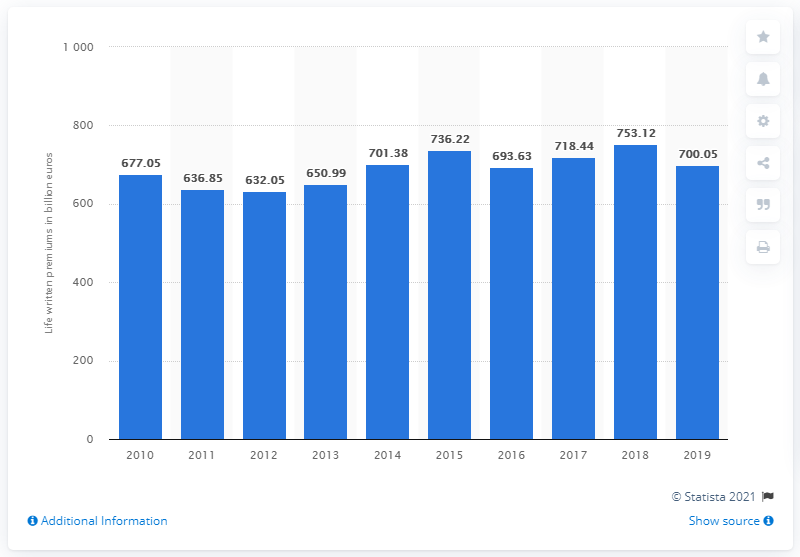Draw attention to some important aspects in this diagram. The direct gross written premiums on the European life insurance market in 2019 were approximately 700.05. According to the European life insurance market in 2019, the total amount of direct gross written premiums was 753.12. In 2018, the gross domestic product (GDP) was the highest among all the years. In 2011, companies offering life insurance reported paying a total of 632.05 in premiums to customers. In 2015 and 2018, there is a difference of 16.9%. 